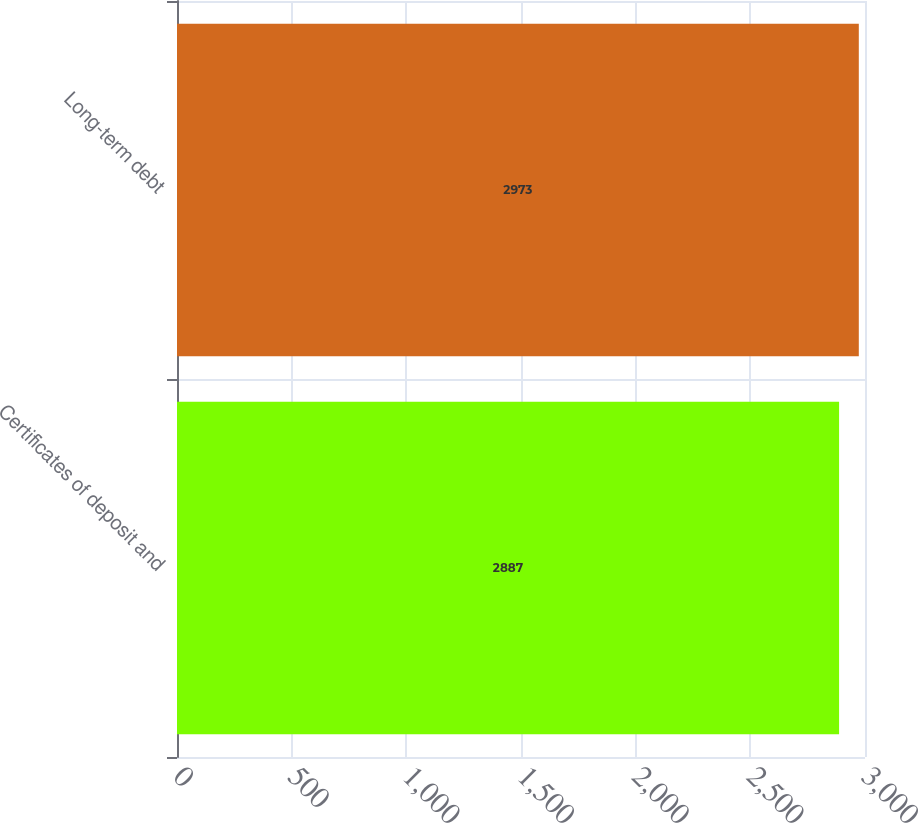Convert chart to OTSL. <chart><loc_0><loc_0><loc_500><loc_500><bar_chart><fcel>Certificates of deposit and<fcel>Long-term debt<nl><fcel>2887<fcel>2973<nl></chart> 